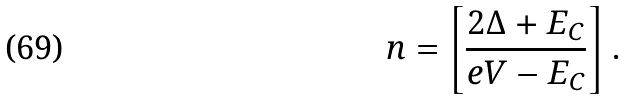<formula> <loc_0><loc_0><loc_500><loc_500>n = \left [ \frac { 2 \Delta + E _ { C } } { e V - E _ { C } } \right ] .</formula> 